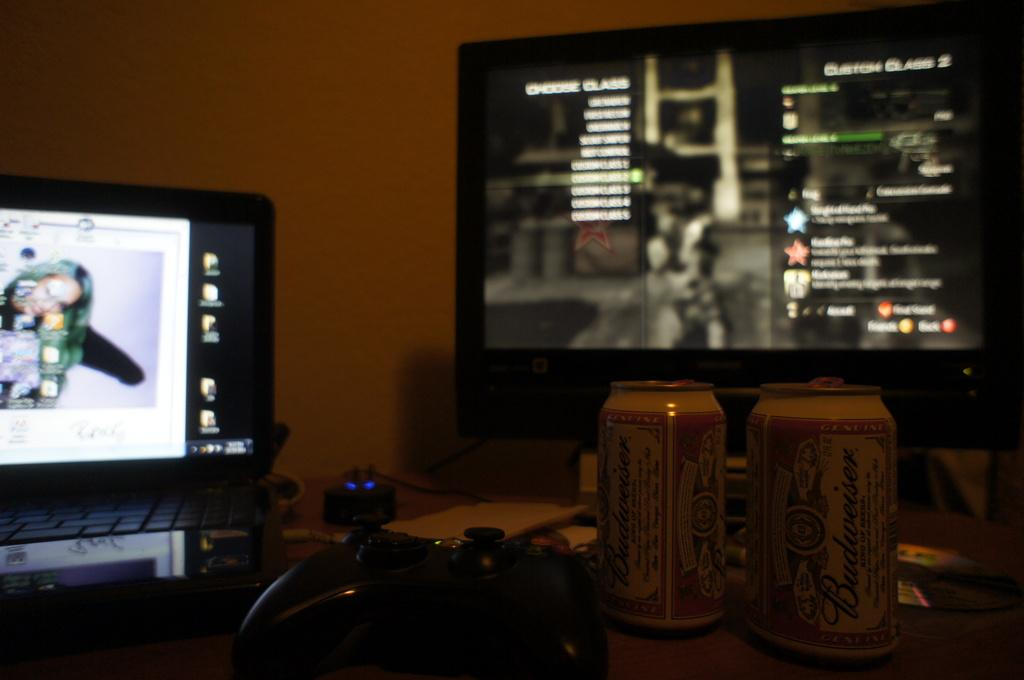<image>
Provide a brief description of the given image. Two cans of Budweiser sit on a desk with two computer monitors, one of which is displaying a video game asking the player to choose their class. 